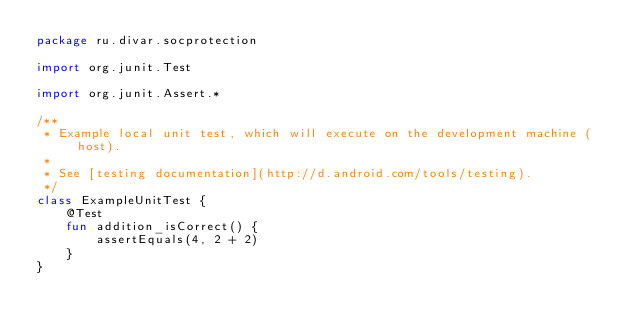Convert code to text. <code><loc_0><loc_0><loc_500><loc_500><_Kotlin_>package ru.divar.socprotection

import org.junit.Test

import org.junit.Assert.*

/**
 * Example local unit test, which will execute on the development machine (host).
 *
 * See [testing documentation](http://d.android.com/tools/testing).
 */
class ExampleUnitTest {
    @Test
    fun addition_isCorrect() {
        assertEquals(4, 2 + 2)
    }
}</code> 